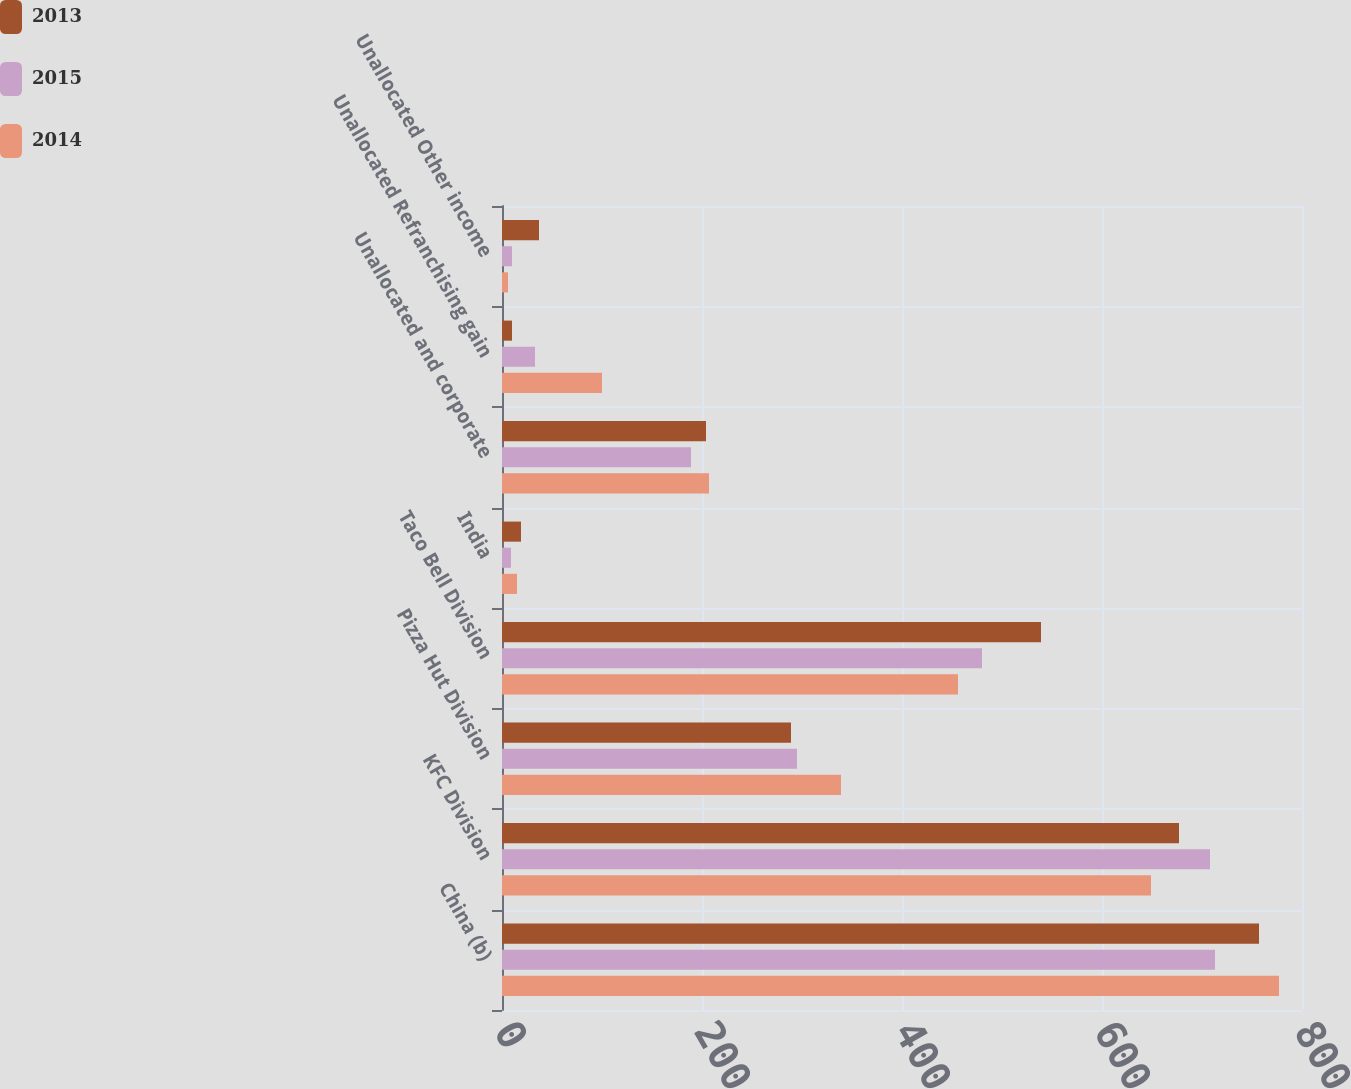Convert chart to OTSL. <chart><loc_0><loc_0><loc_500><loc_500><stacked_bar_chart><ecel><fcel>China (b)<fcel>KFC Division<fcel>Pizza Hut Division<fcel>Taco Bell Division<fcel>India<fcel>Unallocated and corporate<fcel>Unallocated Refranchising gain<fcel>Unallocated Other income<nl><fcel>2013<fcel>757<fcel>677<fcel>289<fcel>539<fcel>19<fcel>204<fcel>10<fcel>37<nl><fcel>2015<fcel>713<fcel>708<fcel>295<fcel>480<fcel>9<fcel>189<fcel>33<fcel>10<nl><fcel>2014<fcel>777<fcel>649<fcel>339<fcel>456<fcel>15<fcel>207<fcel>100<fcel>6<nl></chart> 